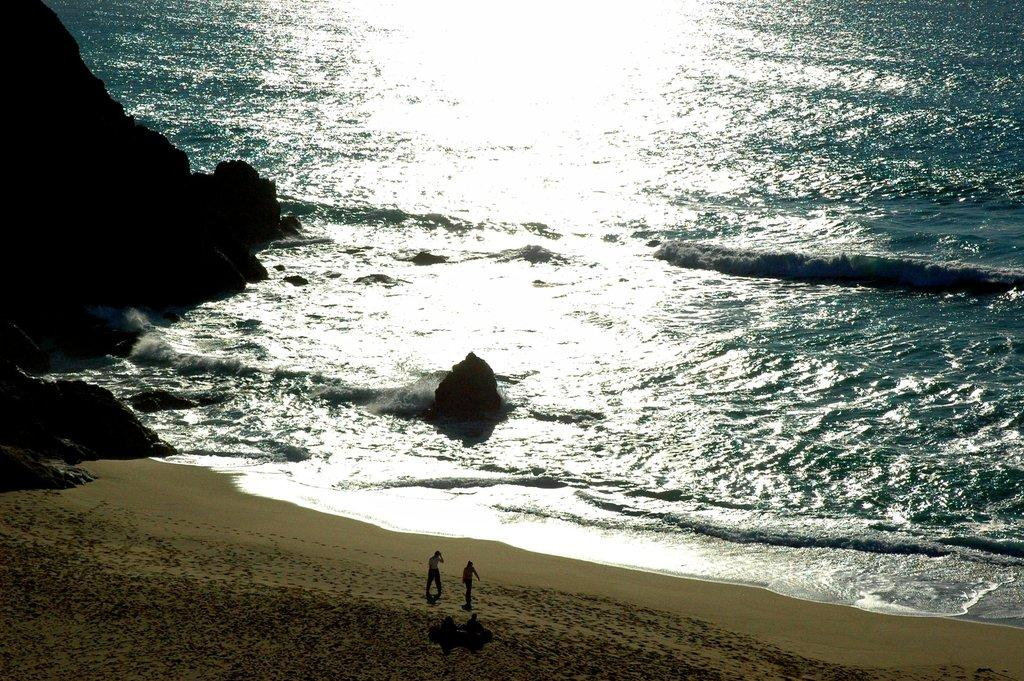How many people are in the image? There are two persons in the image. Where was the image taken? The image was clicked near the beach. What type of terrain is visible at the bottom of the image? There is sand and water visible at the bottom of the image. What can be seen on the left side of the image? There are rocks on the left side of the image. Where is the faucet located in the image? There is no faucet present in the image. What type of scene is depicted in the image? The image depicts a scene near the beach, with sand, water, and rocks visible. 